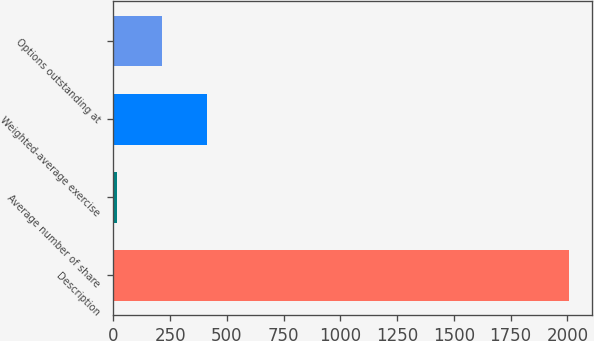Convert chart to OTSL. <chart><loc_0><loc_0><loc_500><loc_500><bar_chart><fcel>Description<fcel>Average number of share<fcel>Weighted-average exercise<fcel>Options outstanding at<nl><fcel>2008<fcel>15.6<fcel>414.08<fcel>214.84<nl></chart> 